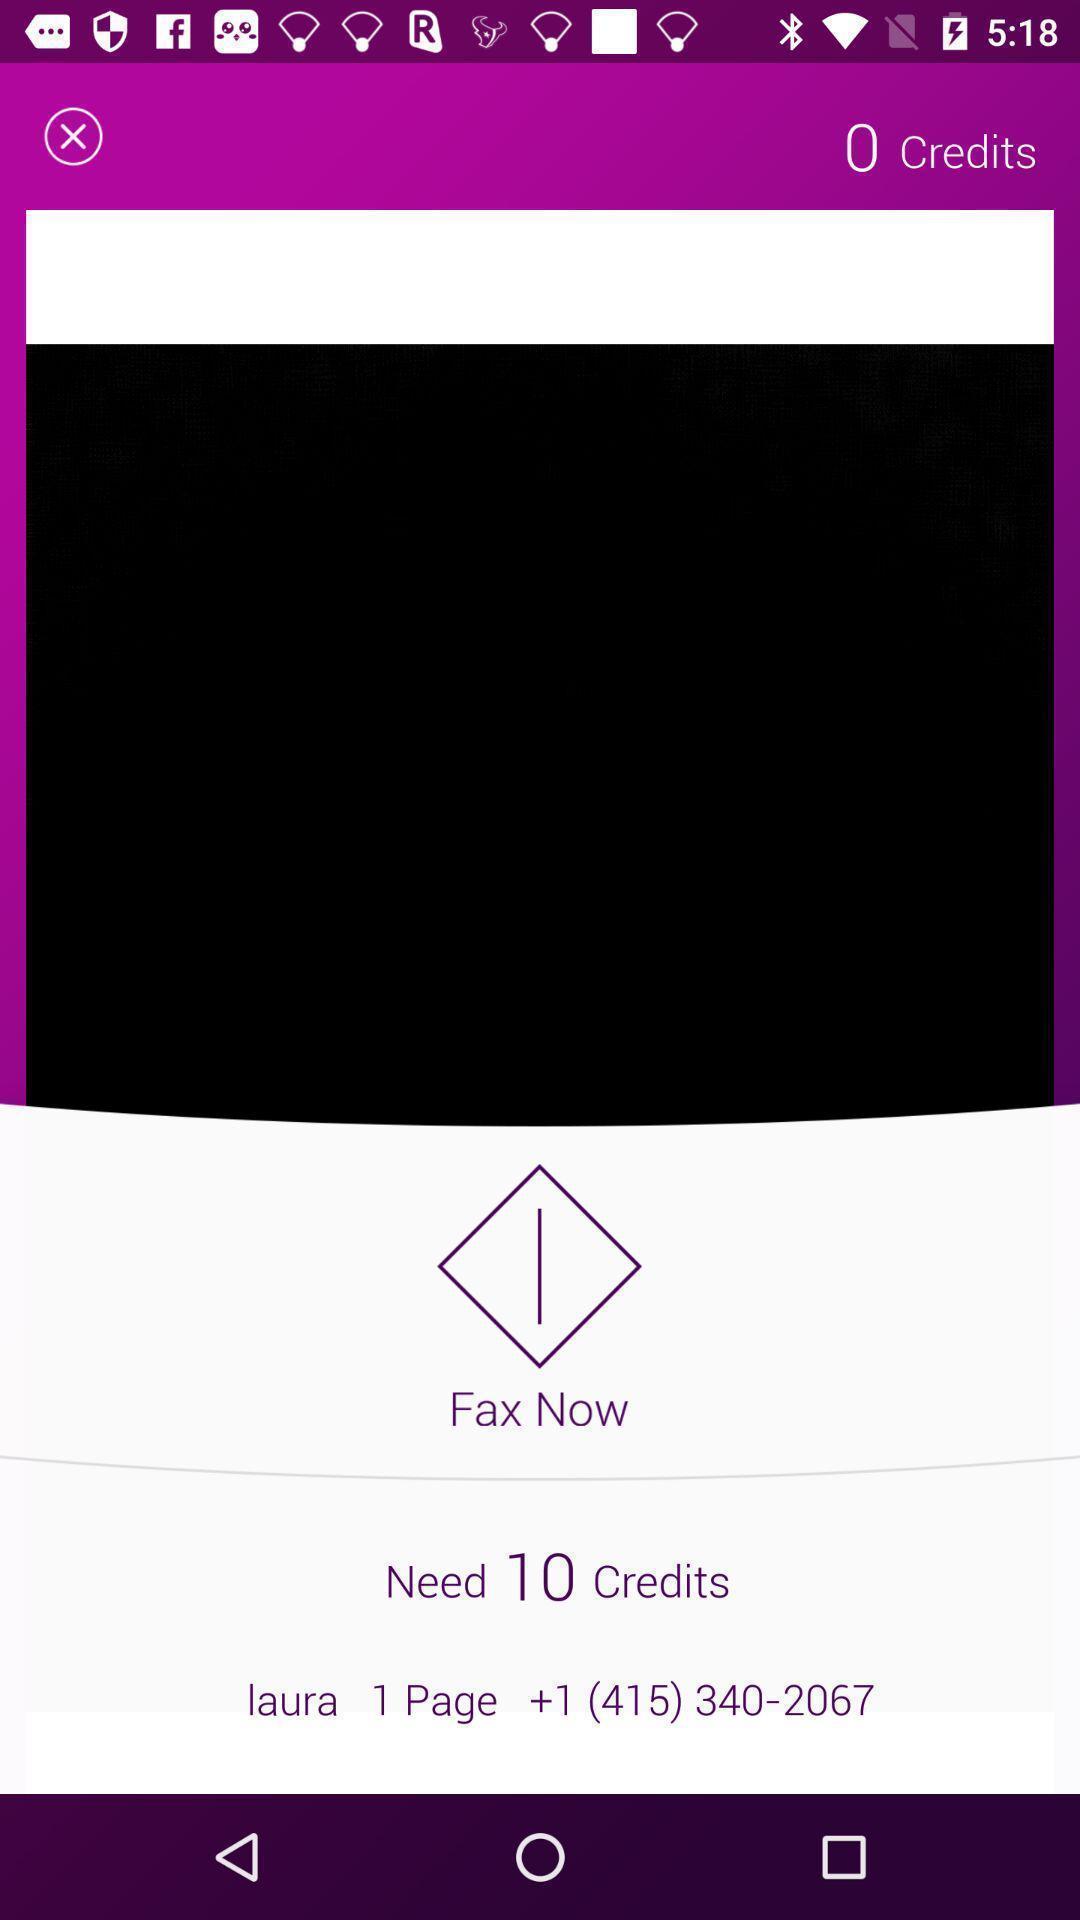Provide a description of this screenshot. Page displaying the details to about managing the fax. 